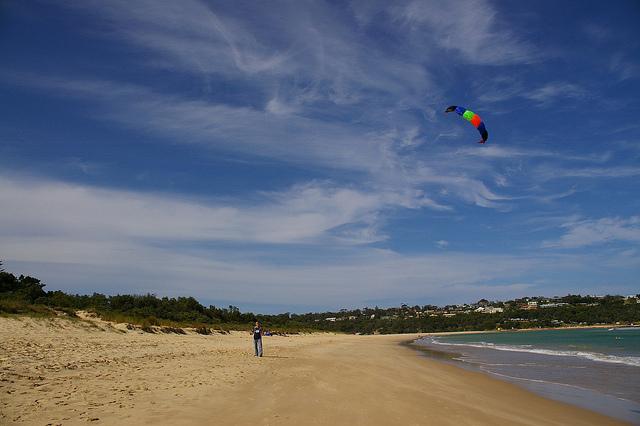What color are the clouds?
Keep it brief. White. Is the water warm?
Give a very brief answer. Yes. Should this man's friends find him easier to spot than most?
Write a very short answer. Yes. Is anyone holding onto the kite?
Keep it brief. Yes. Is this person by the beach?
Give a very brief answer. Yes. What is the guy doing?
Concise answer only. Flying kite. 